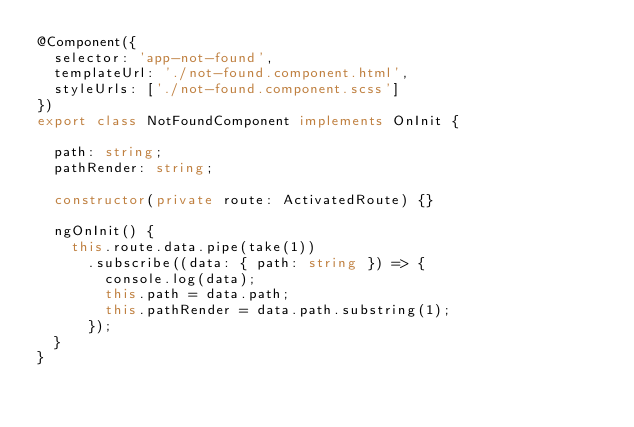<code> <loc_0><loc_0><loc_500><loc_500><_TypeScript_>@Component({
  selector: 'app-not-found',
  templateUrl: './not-found.component.html',
  styleUrls: ['./not-found.component.scss']
})
export class NotFoundComponent implements OnInit {

  path: string;
  pathRender: string;

  constructor(private route: ActivatedRoute) {}

  ngOnInit() {
    this.route.data.pipe(take(1))
      .subscribe((data: { path: string }) => {
        console.log(data);
        this.path = data.path;
        this.pathRender = data.path.substring(1);
      });
  }
}
</code> 